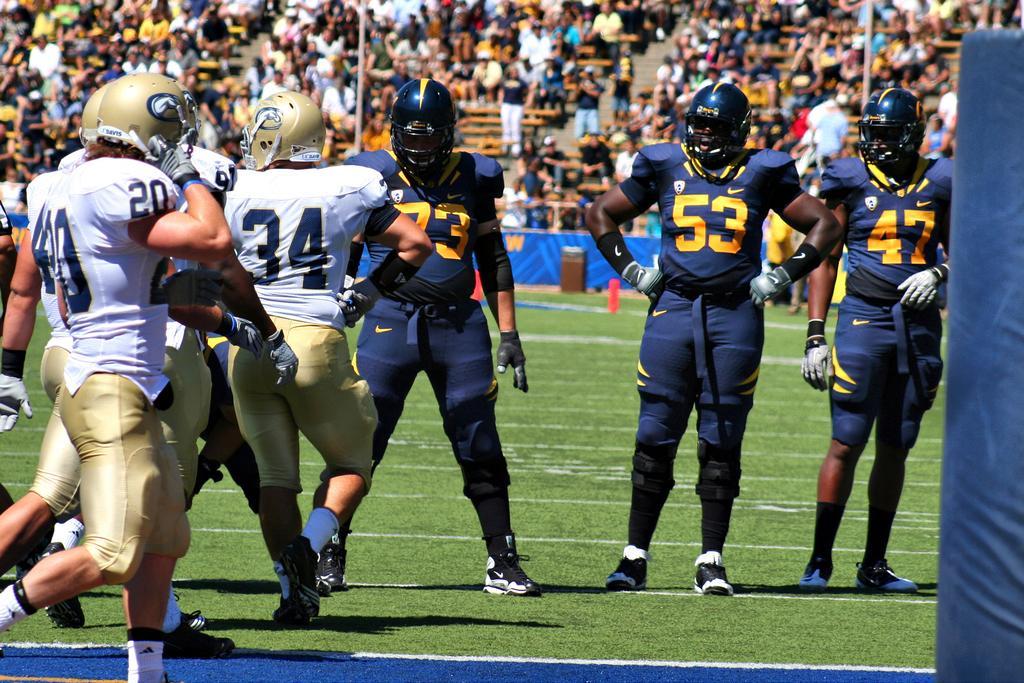Can you describe this image briefly? As we can see in the image there are few people here and there. People in the front are wearing helmets. There is grass, banner, chairs and stairs. 